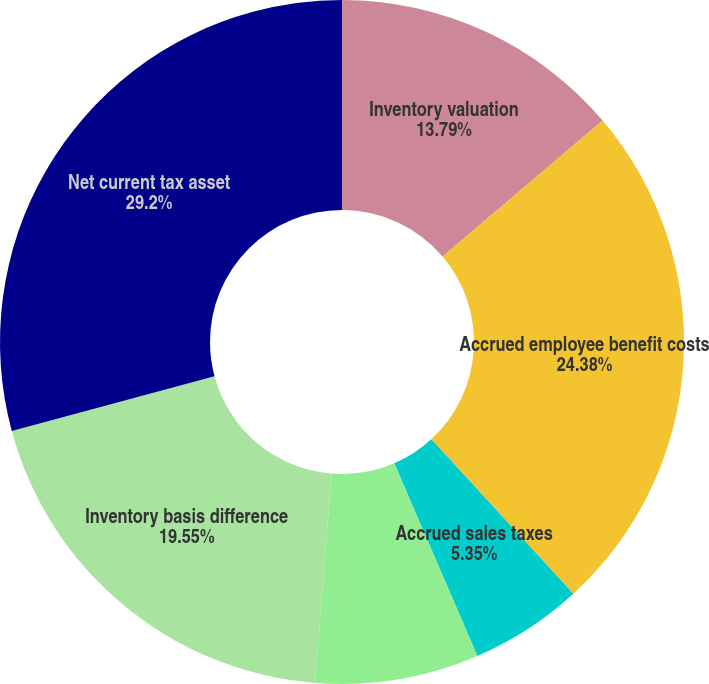<chart> <loc_0><loc_0><loc_500><loc_500><pie_chart><fcel>Inventory valuation<fcel>Accrued employee benefit costs<fcel>Accrued sales taxes<fcel>Other<fcel>Inventory basis difference<fcel>Net current tax asset<nl><fcel>13.79%<fcel>24.38%<fcel>5.35%<fcel>7.73%<fcel>19.55%<fcel>29.19%<nl></chart> 